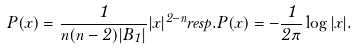<formula> <loc_0><loc_0><loc_500><loc_500>P ( x ) = \frac { 1 } { n ( n - 2 ) | B _ { 1 } | } | x | ^ { 2 - n } r e s p . P ( x ) = - \frac { 1 } { 2 \pi } \log | x | .</formula> 